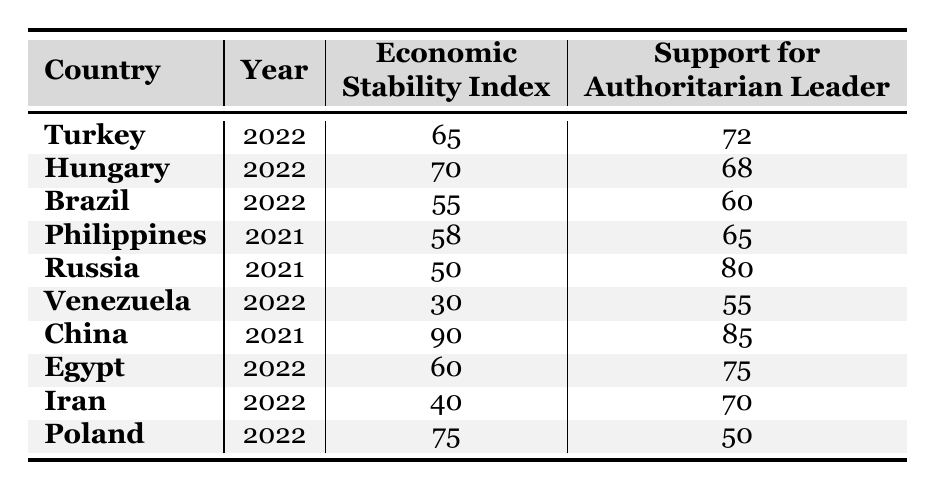What is the economic stability index for China in 2021? The table shows that China has an economic stability index of 90 in 2021.
Answer: 90 Which country has the highest support for an authoritarian leader? According to the table, Russia has the highest support for an authoritarian leader at 80.
Answer: Russia What is the average economic stability index across all listed countries? To find the average, sum the indices: (65 + 70 + 55 + 58 + 50 + 30 + 90 + 60 + 40 + 75) = 700. There are 10 countries, so the average is 700 / 10 = 70.
Answer: 70 Is the support for authoritarian leaders higher in countries with lower economic stability? Looking at the table, Venezuela (30) has lower economic stability and support at 55, while China (90) has high stability and support at 85. This indicates that lower stability doesn't always mean higher support, so the answer is no.
Answer: No What is the difference in support for authoritarian leaders between Turkey and Poland? Turkey has support for authoritarian leaders at 72, while Poland has an index of 50. The difference is calculated as 72 - 50 = 22.
Answer: 22 Which country has the lowest economic stability index and what is its support for an authoritarian leader? Venezuela has the lowest economic stability index at 30, with support for an authoritarian leader at 55.
Answer: Venezuela, 55 Are there any countries where the economic stability index is above 70 with support for authoritarian leaders below 70? The table shows Hungary with an index of 70 and support at 68, satisfying this condition. Thus, yes, there is a country that meets this criterion.
Answer: Yes How many countries have an economic stability index below 60? The countries with an index below 60 are Brazil (55), Philippines (58), Venezuela (30), and Iran (40), totaling 4 countries.
Answer: 4 What is the correlation between economic stability and support for an authoritarian leader based on this data? Analyzing the relationship, higher economic stability (like China and Turkey) tends to correlate with higher support for authoritarian leaders, whereas lower stability (like Venezuela and Russia) shows varying levels of support. This requires more analytical methods for a precise correlation coefficient.
Answer: Positive correlation Considering data trends, what might a high economic stability index indicate about a country's support for authoritarian leaders? The table shows that higher economic stability indices often coincide with higher support levels, suggesting that populations may support stability in leadership amidst economic realization. However, contextual factors must also be considered.
Answer: Higher support levels 